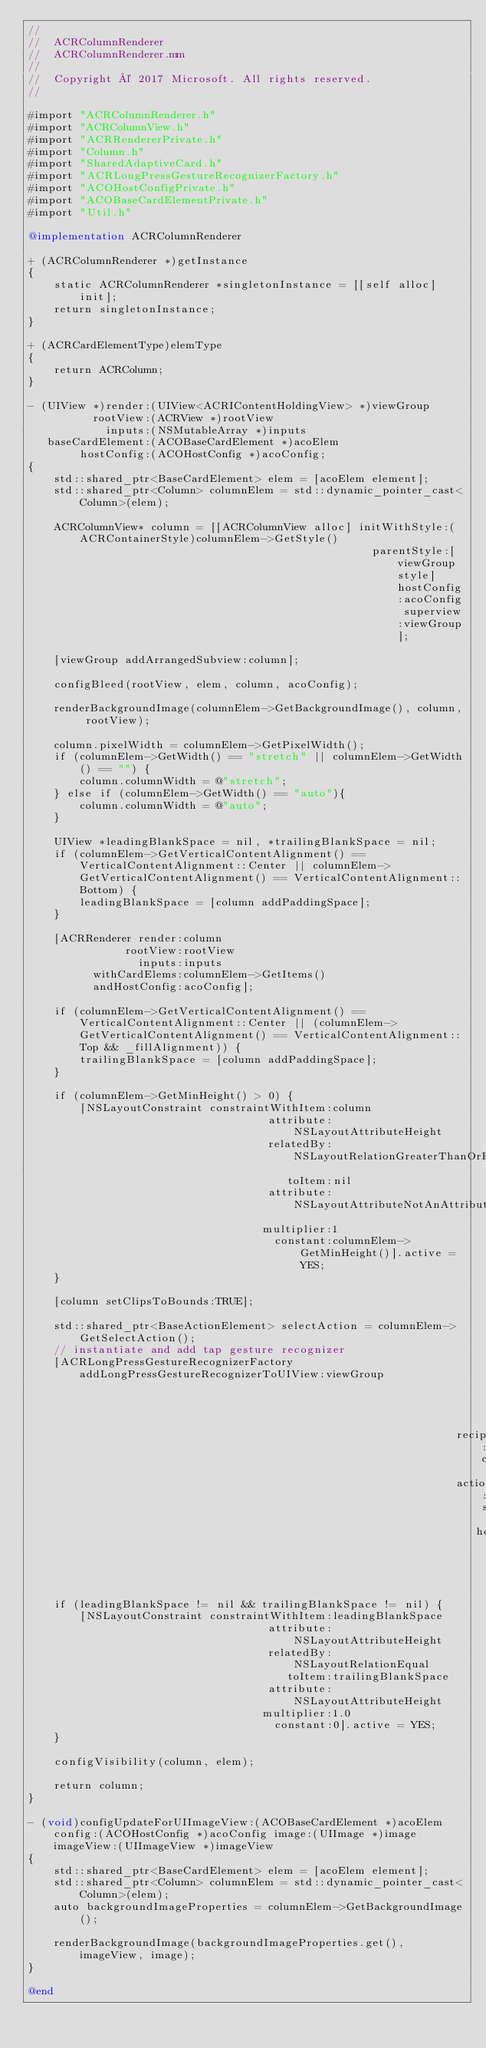Convert code to text. <code><loc_0><loc_0><loc_500><loc_500><_ObjectiveC_>//
//  ACRColumnRenderer
//  ACRColumnRenderer.mm
//
//  Copyright © 2017 Microsoft. All rights reserved.
//

#import "ACRColumnRenderer.h"
#import "ACRColumnView.h"
#import "ACRRendererPrivate.h"
#import "Column.h"
#import "SharedAdaptiveCard.h"
#import "ACRLongPressGestureRecognizerFactory.h"
#import "ACOHostConfigPrivate.h"
#import "ACOBaseCardElementPrivate.h"
#import "Util.h"

@implementation ACRColumnRenderer

+ (ACRColumnRenderer *)getInstance
{
    static ACRColumnRenderer *singletonInstance = [[self alloc] init];
    return singletonInstance;
}

+ (ACRCardElementType)elemType
{
    return ACRColumn;
}

- (UIView *)render:(UIView<ACRIContentHoldingView> *)viewGroup
          rootView:(ACRView *)rootView
            inputs:(NSMutableArray *)inputs
   baseCardElement:(ACOBaseCardElement *)acoElem
        hostConfig:(ACOHostConfig *)acoConfig;
{
    std::shared_ptr<BaseCardElement> elem = [acoElem element];
    std::shared_ptr<Column> columnElem = std::dynamic_pointer_cast<Column>(elem);

    ACRColumnView* column = [[ACRColumnView alloc] initWithStyle:(ACRContainerStyle)columnElem->GetStyle()
                                                     parentStyle:[viewGroup style] hostConfig:acoConfig superview:viewGroup];

    [viewGroup addArrangedSubview:column];
    
    configBleed(rootView, elem, column, acoConfig);
        
    renderBackgroundImage(columnElem->GetBackgroundImage(), column, rootView);
    
    column.pixelWidth = columnElem->GetPixelWidth();
    if (columnElem->GetWidth() == "stretch" || columnElem->GetWidth() == "") {
        column.columnWidth = @"stretch";
    } else if (columnElem->GetWidth() == "auto"){
        column.columnWidth = @"auto";
    }

    UIView *leadingBlankSpace = nil, *trailingBlankSpace = nil;
    if (columnElem->GetVerticalContentAlignment() == VerticalContentAlignment::Center || columnElem->GetVerticalContentAlignment() == VerticalContentAlignment::Bottom) {
        leadingBlankSpace = [column addPaddingSpace];
    }

    [ACRRenderer render:column
               rootView:rootView
                 inputs:inputs
          withCardElems:columnElem->GetItems()
          andHostConfig:acoConfig];

    if (columnElem->GetVerticalContentAlignment() == VerticalContentAlignment::Center || (columnElem->GetVerticalContentAlignment() == VerticalContentAlignment::Top && _fillAlignment)) {
        trailingBlankSpace = [column addPaddingSpace];
    }

    if (columnElem->GetMinHeight() > 0) {
        [NSLayoutConstraint constraintWithItem:column
                                     attribute:NSLayoutAttributeHeight
                                     relatedBy:NSLayoutRelationGreaterThanOrEqual
                                        toItem:nil
                                     attribute:NSLayoutAttributeNotAnAttribute
                                    multiplier:1
                                      constant:columnElem->GetMinHeight()].active = YES;
    }

    [column setClipsToBounds:TRUE];

    std::shared_ptr<BaseActionElement> selectAction = columnElem->GetSelectAction();
    // instantiate and add tap gesture recognizer
    [ACRLongPressGestureRecognizerFactory addLongPressGestureRecognizerToUIView:viewGroup
                                                                       rootView:rootView
                                                                  recipientView:column
                                                                  actionElement:selectAction
                                                                     hostConfig:acoConfig];

    if (leadingBlankSpace != nil && trailingBlankSpace != nil) {
        [NSLayoutConstraint constraintWithItem:leadingBlankSpace
                                     attribute:NSLayoutAttributeHeight
                                     relatedBy:NSLayoutRelationEqual
                                        toItem:trailingBlankSpace
                                     attribute:NSLayoutAttributeHeight
                                    multiplier:1.0
                                      constant:0].active = YES;
    }

    configVisibility(column, elem);

    return column;
}

- (void)configUpdateForUIImageView:(ACOBaseCardElement *)acoElem config:(ACOHostConfig *)acoConfig image:(UIImage *)image imageView:(UIImageView *)imageView
{
    std::shared_ptr<BaseCardElement> elem = [acoElem element];
    std::shared_ptr<Column> columnElem = std::dynamic_pointer_cast<Column>(elem);
    auto backgroundImageProperties = columnElem->GetBackgroundImage();
    
    renderBackgroundImage(backgroundImageProperties.get(), imageView, image);
}

@end
</code> 